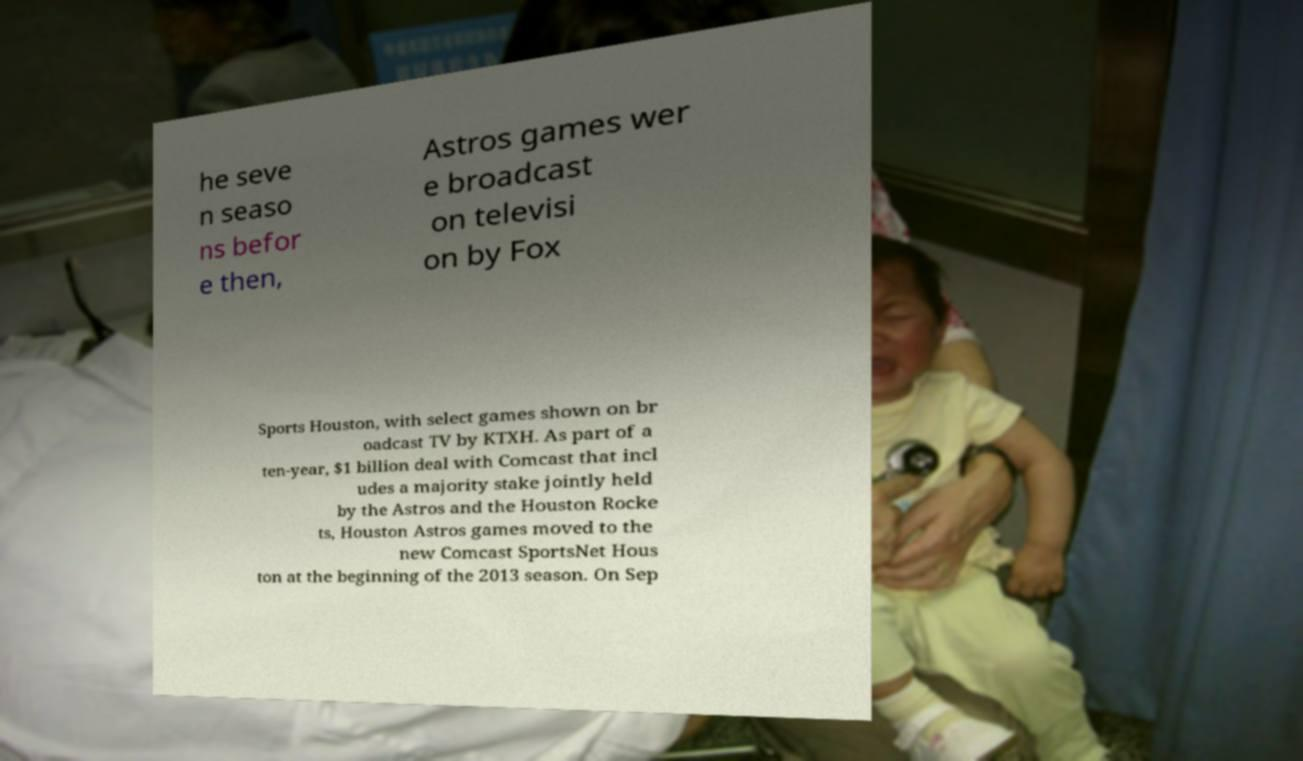There's text embedded in this image that I need extracted. Can you transcribe it verbatim? he seve n seaso ns befor e then, Astros games wer e broadcast on televisi on by Fox Sports Houston, with select games shown on br oadcast TV by KTXH. As part of a ten-year, $1 billion deal with Comcast that incl udes a majority stake jointly held by the Astros and the Houston Rocke ts, Houston Astros games moved to the new Comcast SportsNet Hous ton at the beginning of the 2013 season. On Sep 